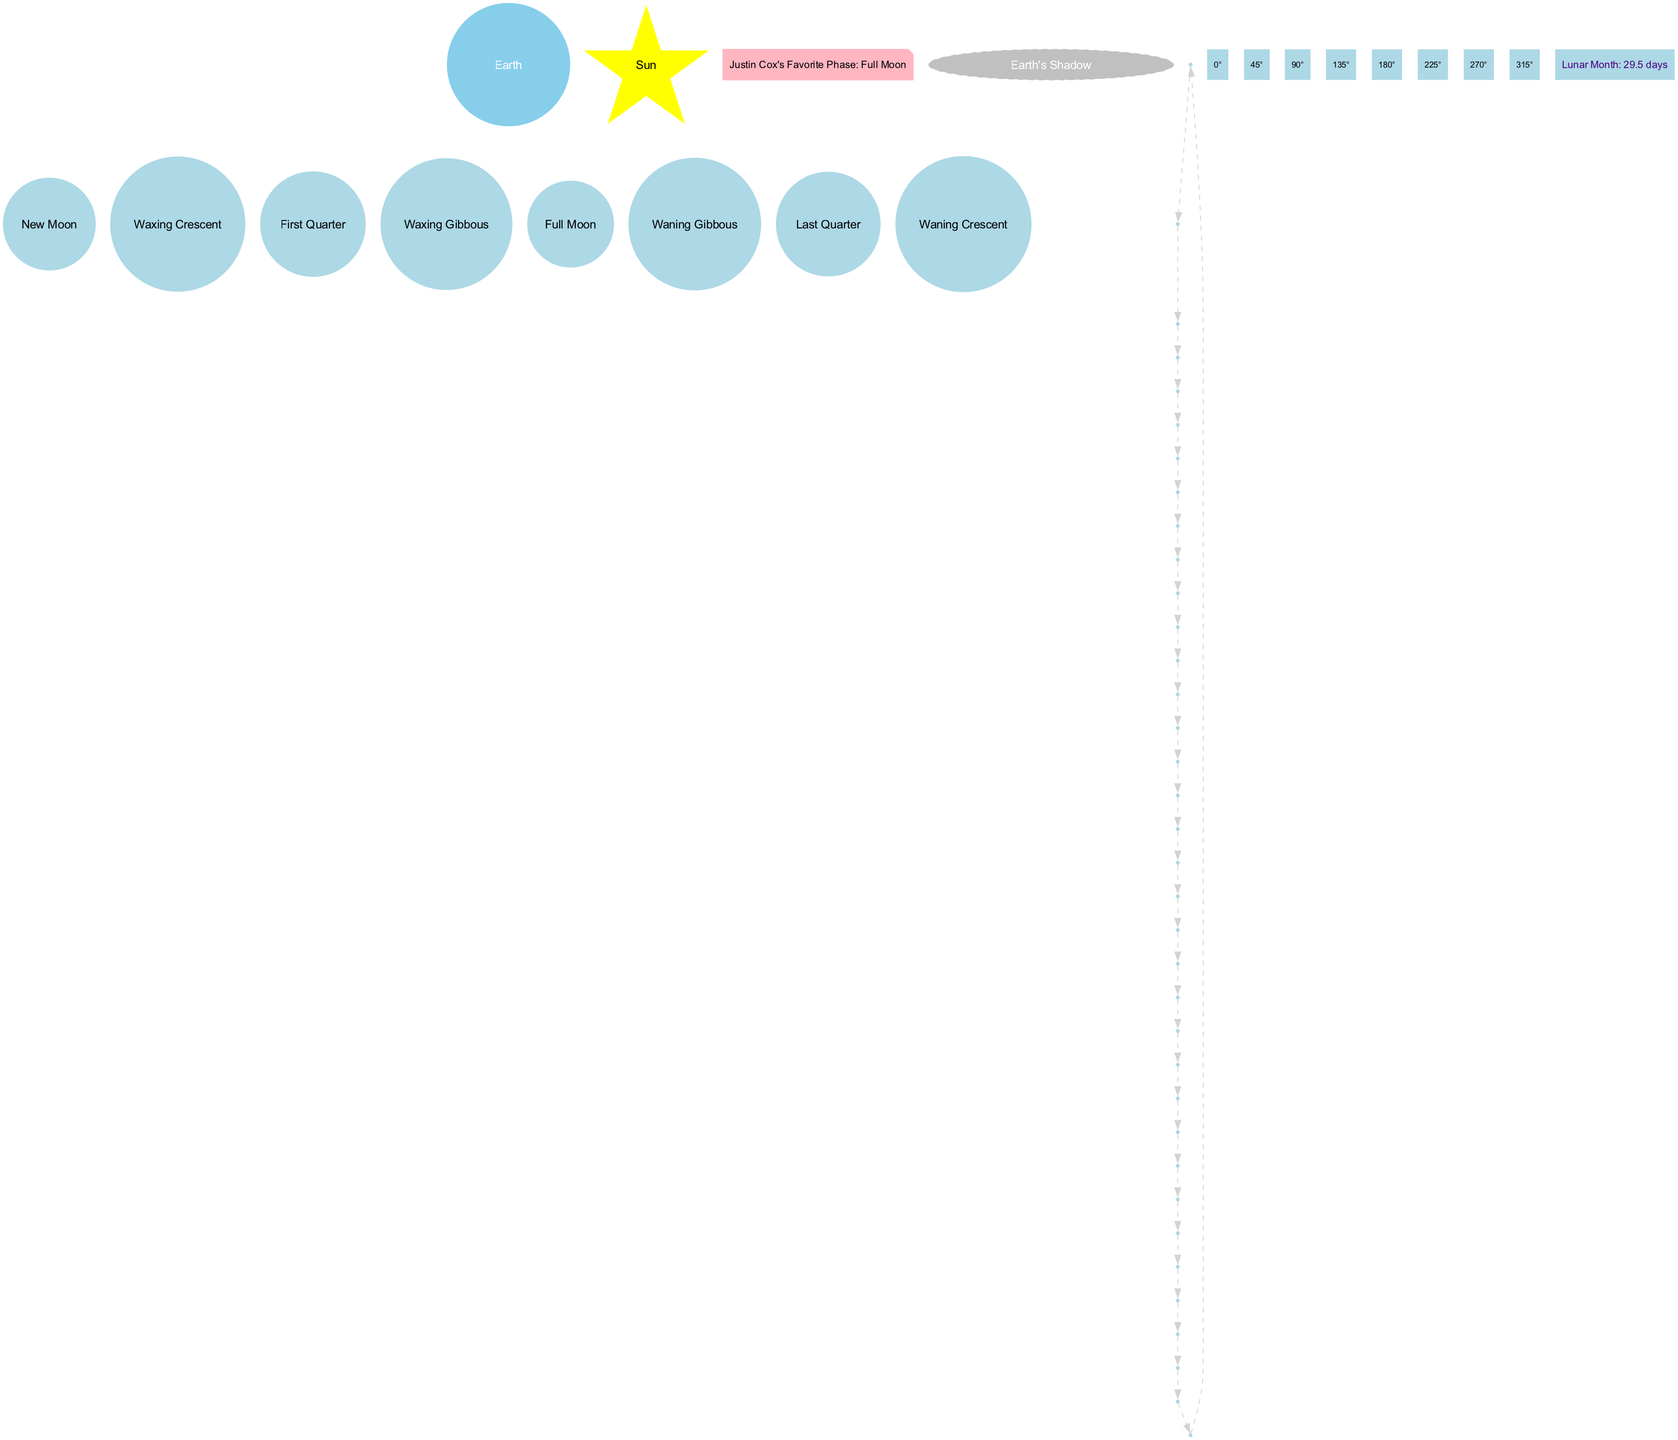What is the central object in the diagram? The diagram identifies the central object as "Earth." This can be found at the center of the diagram where the Earth node is displayed.
Answer: Earth How many phases of the Moon are shown? The diagram represents 8 distinct phases of the Moon. These are listed in the phases section and each phase is depicted by a node around the Earth.
Answer: 8 What is Justin Cox's favorite phase of the Moon? The diagram includes a node that specifically states "Justin Cox's Favorite Phase: Full Moon." This information can be found easily by looking for the corresponding note node.
Answer: Full Moon What is the angle of sunlight during the Full Moon phase? During the Full Moon phase, the sunlight angle is "180°," as indicated in the sunlight angles section of the diagram, which corresponds with the position of the Full Moon.
Answer: 180° Which Moon phase follows the Last Quarter? According to the sequence of Moon phases provided in the diagram, the phase that follows the Last Quarter is the Waning Crescent, as the phases are listed in a circular order around the Earth.
Answer: Waning Crescent What is the shape of Earth's shadow in the diagram? The Earth's shadow is represented by an ellipse in the diagram, which is specifically labeled as "Earth's Shadow." This can be identified by locating the shadow node positioned on one side of the Earth node.
Answer: Ellipse What is the timeframe for the lunar month depicted in the diagram? The timeframe for the lunar month is specified in the diagram as "29.5 days." This information is presented in a node that is positioned above the central Earth node.
Answer: 29.5 days At what angle does the sunlight reach the New Moon phase? The sunlight angle during the New Moon phase is "0°," as shown in the sunlight angles section of the diagram, which aligns with the position of the New Moon.
Answer: 0° What type of graph is used to depict the Moon's orbit? The diagram uses a directed graph with circular connections to illustrate the "Moon's Orbit," which encircles the central node of the Earth. This can be seen by the interconnected dashed edges forming a circle.
Answer: Directed graph 